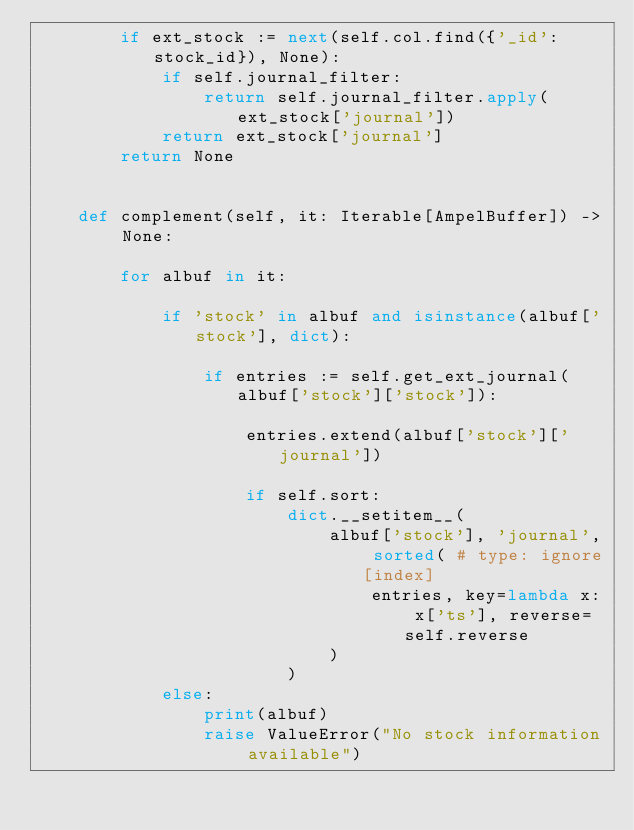<code> <loc_0><loc_0><loc_500><loc_500><_Python_>		if ext_stock := next(self.col.find({'_id': stock_id}), None):
			if self.journal_filter:
				return self.journal_filter.apply(ext_stock['journal'])
			return ext_stock['journal']
		return None


	def complement(self, it: Iterable[AmpelBuffer]) -> None:

		for albuf in it:

			if 'stock' in albuf and isinstance(albuf['stock'], dict):

				if entries := self.get_ext_journal(albuf['stock']['stock']):

					entries.extend(albuf['stock']['journal'])

					if self.sort:
						dict.__setitem__(
							albuf['stock'], 'journal', sorted( # type: ignore[index]
								entries, key=lambda x: x['ts'], reverse=self.reverse
							)
						)
			else:
				print(albuf)
				raise ValueError("No stock information available")
</code> 